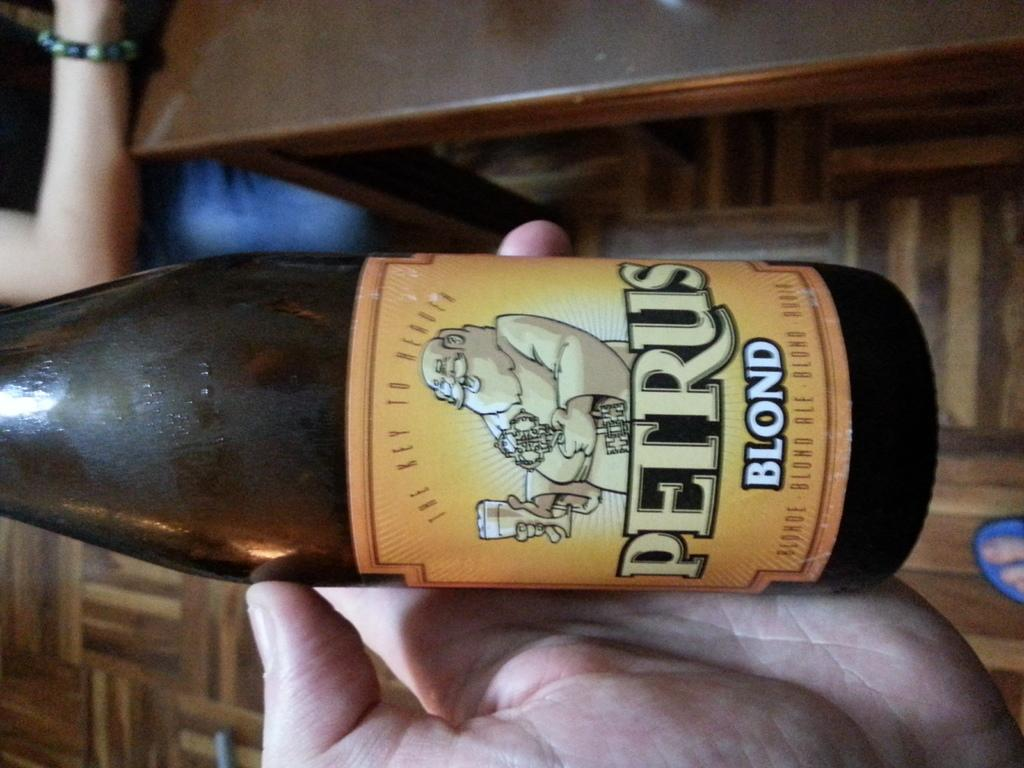Provide a one-sentence caption for the provided image. Someone is holding a bottle of Petru blond beer in their hand. 